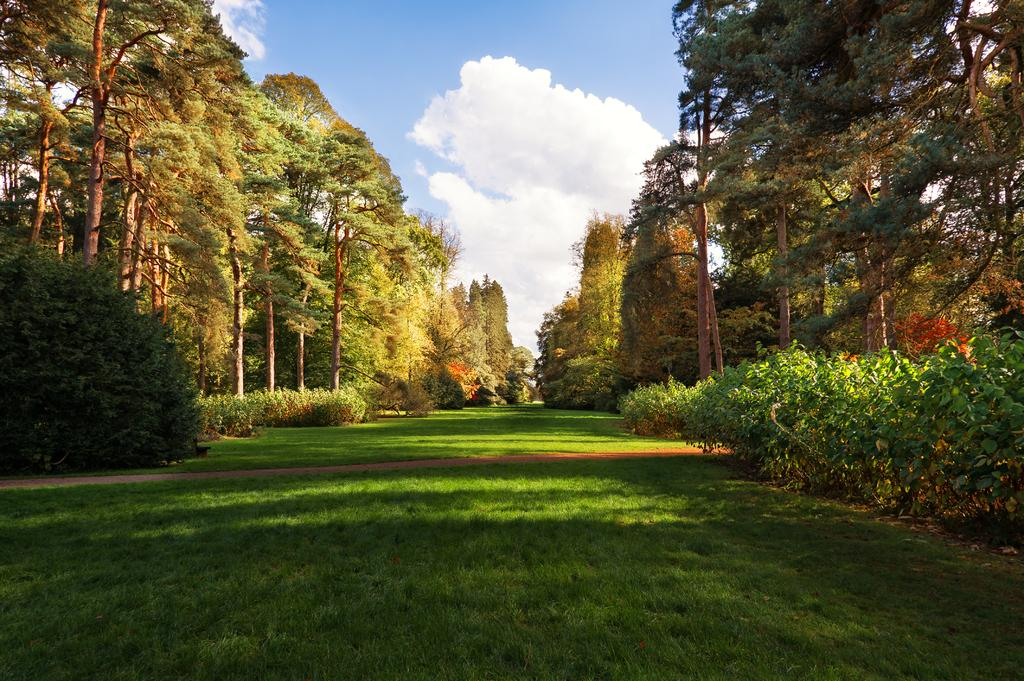What type of vegetation is visible in front of the image? There is grass in front of the image. What other types of vegetation can be seen on both sides of the image? There are plants and trees on both sides of the image. What can be seen in the background of the image? The sky is visible in the background of the image. What type of lamp is hanging from the tree on the left side of the image? There is no lamp present in the image; it only features vegetation and the sky. 